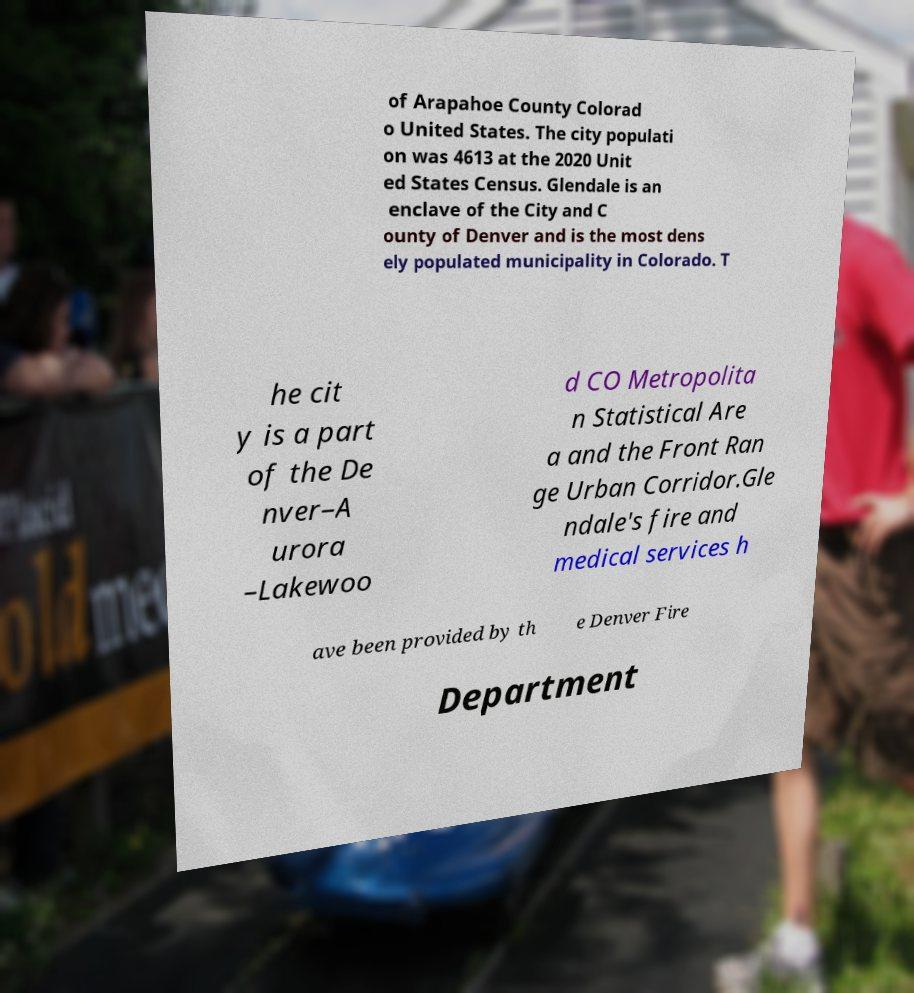I need the written content from this picture converted into text. Can you do that? of Arapahoe County Colorad o United States. The city populati on was 4613 at the 2020 Unit ed States Census. Glendale is an enclave of the City and C ounty of Denver and is the most dens ely populated municipality in Colorado. T he cit y is a part of the De nver–A urora –Lakewoo d CO Metropolita n Statistical Are a and the Front Ran ge Urban Corridor.Gle ndale's fire and medical services h ave been provided by th e Denver Fire Department 